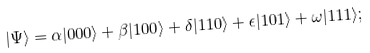<formula> <loc_0><loc_0><loc_500><loc_500>| \Psi \rangle = \alpha | { 0 0 0 } \rangle + \beta | { 1 0 0 } \rangle + \delta | { 1 1 0 } \rangle + \epsilon | { 1 0 1 } \rangle + \omega | { 1 1 1 } \rangle ;</formula> 